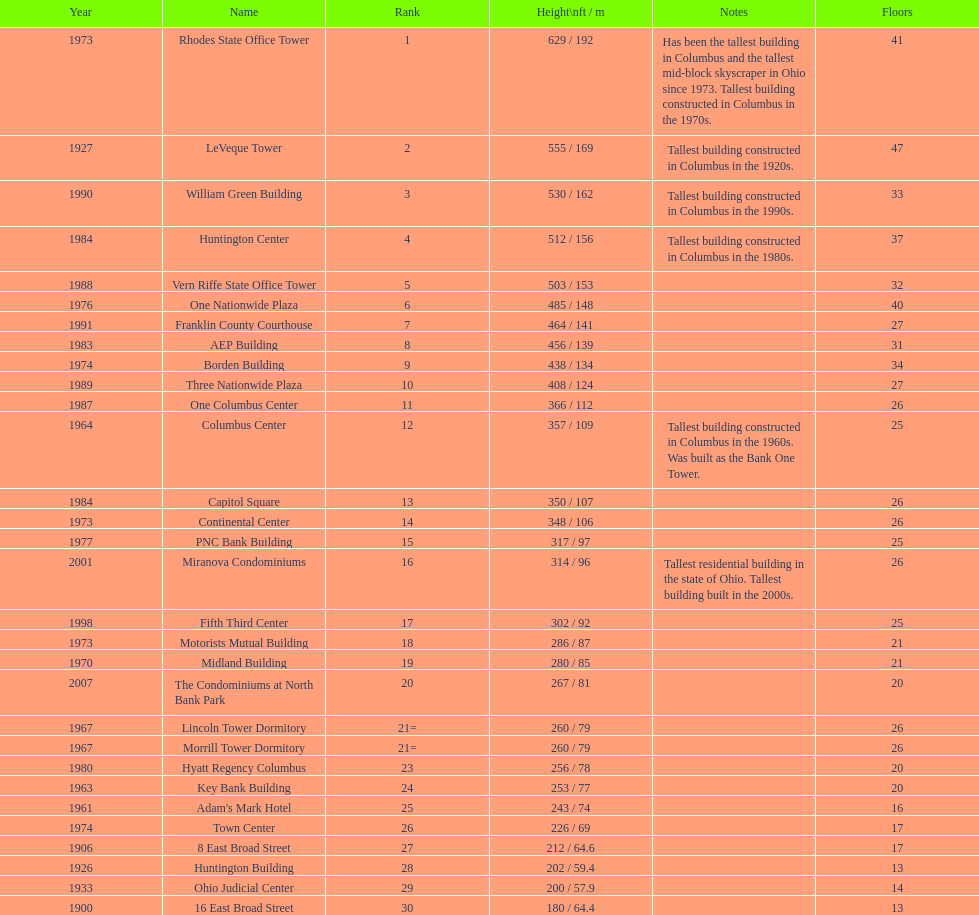How many floors does the capitol square have? 26. 